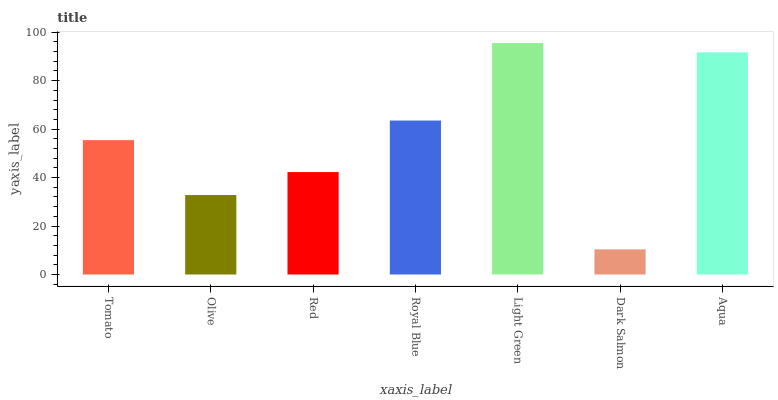Is Dark Salmon the minimum?
Answer yes or no. Yes. Is Light Green the maximum?
Answer yes or no. Yes. Is Olive the minimum?
Answer yes or no. No. Is Olive the maximum?
Answer yes or no. No. Is Tomato greater than Olive?
Answer yes or no. Yes. Is Olive less than Tomato?
Answer yes or no. Yes. Is Olive greater than Tomato?
Answer yes or no. No. Is Tomato less than Olive?
Answer yes or no. No. Is Tomato the high median?
Answer yes or no. Yes. Is Tomato the low median?
Answer yes or no. Yes. Is Aqua the high median?
Answer yes or no. No. Is Aqua the low median?
Answer yes or no. No. 